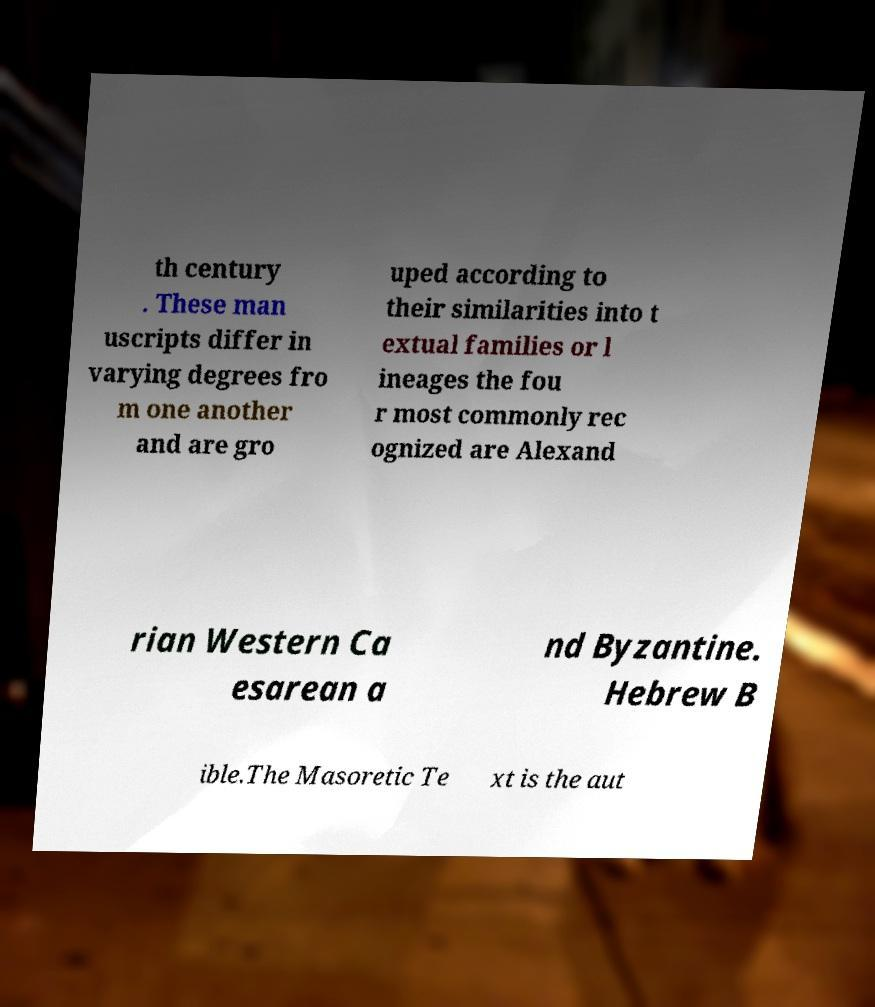Please read and relay the text visible in this image. What does it say? th century . These man uscripts differ in varying degrees fro m one another and are gro uped according to their similarities into t extual families or l ineages the fou r most commonly rec ognized are Alexand rian Western Ca esarean a nd Byzantine. Hebrew B ible.The Masoretic Te xt is the aut 